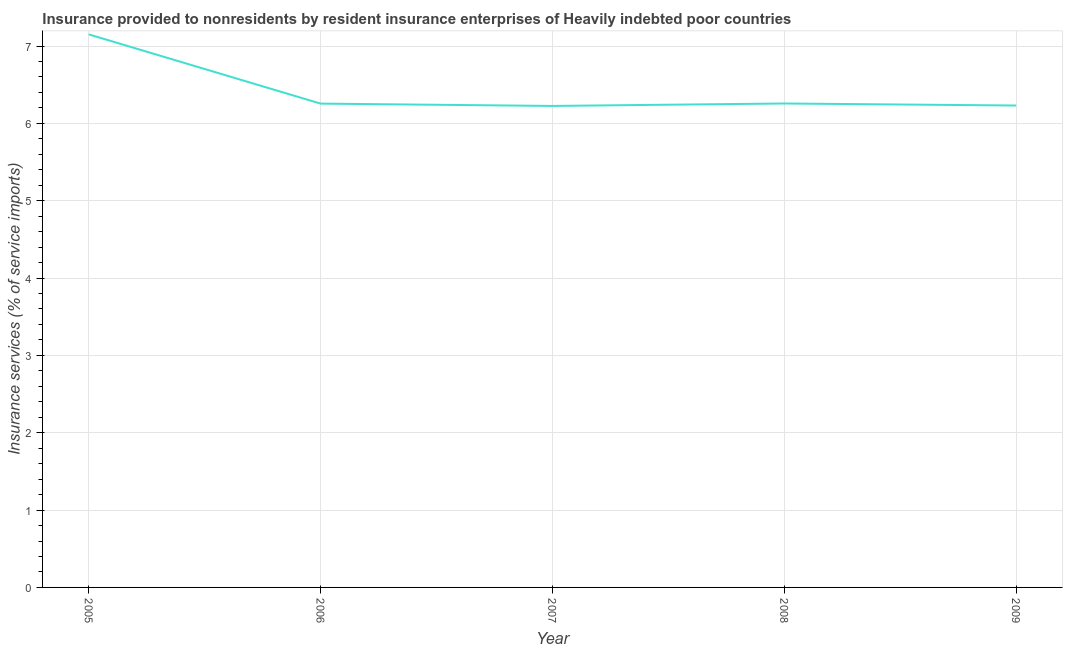What is the insurance and financial services in 2006?
Ensure brevity in your answer.  6.26. Across all years, what is the maximum insurance and financial services?
Offer a terse response. 7.15. Across all years, what is the minimum insurance and financial services?
Ensure brevity in your answer.  6.23. In which year was the insurance and financial services maximum?
Your response must be concise. 2005. In which year was the insurance and financial services minimum?
Your answer should be very brief. 2007. What is the sum of the insurance and financial services?
Provide a short and direct response. 32.12. What is the difference between the insurance and financial services in 2005 and 2007?
Make the answer very short. 0.92. What is the average insurance and financial services per year?
Offer a very short reply. 6.42. What is the median insurance and financial services?
Make the answer very short. 6.26. What is the ratio of the insurance and financial services in 2005 to that in 2008?
Keep it short and to the point. 1.14. Is the insurance and financial services in 2006 less than that in 2007?
Offer a terse response. No. Is the difference between the insurance and financial services in 2006 and 2009 greater than the difference between any two years?
Your answer should be very brief. No. What is the difference between the highest and the second highest insurance and financial services?
Provide a short and direct response. 0.89. Is the sum of the insurance and financial services in 2007 and 2008 greater than the maximum insurance and financial services across all years?
Your answer should be compact. Yes. What is the difference between the highest and the lowest insurance and financial services?
Your answer should be very brief. 0.92. In how many years, is the insurance and financial services greater than the average insurance and financial services taken over all years?
Offer a terse response. 1. Does the insurance and financial services monotonically increase over the years?
Provide a succinct answer. No. How many years are there in the graph?
Offer a terse response. 5. Are the values on the major ticks of Y-axis written in scientific E-notation?
Ensure brevity in your answer.  No. Does the graph contain any zero values?
Your answer should be compact. No. What is the title of the graph?
Your answer should be very brief. Insurance provided to nonresidents by resident insurance enterprises of Heavily indebted poor countries. What is the label or title of the Y-axis?
Make the answer very short. Insurance services (% of service imports). What is the Insurance services (% of service imports) of 2005?
Offer a very short reply. 7.15. What is the Insurance services (% of service imports) in 2006?
Keep it short and to the point. 6.26. What is the Insurance services (% of service imports) in 2007?
Your response must be concise. 6.23. What is the Insurance services (% of service imports) in 2008?
Give a very brief answer. 6.26. What is the Insurance services (% of service imports) of 2009?
Ensure brevity in your answer.  6.23. What is the difference between the Insurance services (% of service imports) in 2005 and 2006?
Your answer should be compact. 0.89. What is the difference between the Insurance services (% of service imports) in 2005 and 2007?
Keep it short and to the point. 0.92. What is the difference between the Insurance services (% of service imports) in 2005 and 2008?
Your answer should be compact. 0.89. What is the difference between the Insurance services (% of service imports) in 2005 and 2009?
Your answer should be very brief. 0.92. What is the difference between the Insurance services (% of service imports) in 2006 and 2007?
Offer a very short reply. 0.03. What is the difference between the Insurance services (% of service imports) in 2006 and 2008?
Your answer should be very brief. -0. What is the difference between the Insurance services (% of service imports) in 2006 and 2009?
Offer a very short reply. 0.02. What is the difference between the Insurance services (% of service imports) in 2007 and 2008?
Provide a succinct answer. -0.03. What is the difference between the Insurance services (% of service imports) in 2007 and 2009?
Give a very brief answer. -0.01. What is the difference between the Insurance services (% of service imports) in 2008 and 2009?
Ensure brevity in your answer.  0.03. What is the ratio of the Insurance services (% of service imports) in 2005 to that in 2006?
Keep it short and to the point. 1.14. What is the ratio of the Insurance services (% of service imports) in 2005 to that in 2007?
Your answer should be very brief. 1.15. What is the ratio of the Insurance services (% of service imports) in 2005 to that in 2008?
Your answer should be compact. 1.14. What is the ratio of the Insurance services (% of service imports) in 2005 to that in 2009?
Ensure brevity in your answer.  1.15. What is the ratio of the Insurance services (% of service imports) in 2006 to that in 2007?
Provide a succinct answer. 1. What is the ratio of the Insurance services (% of service imports) in 2006 to that in 2009?
Provide a succinct answer. 1. What is the ratio of the Insurance services (% of service imports) in 2007 to that in 2008?
Make the answer very short. 0.99. 